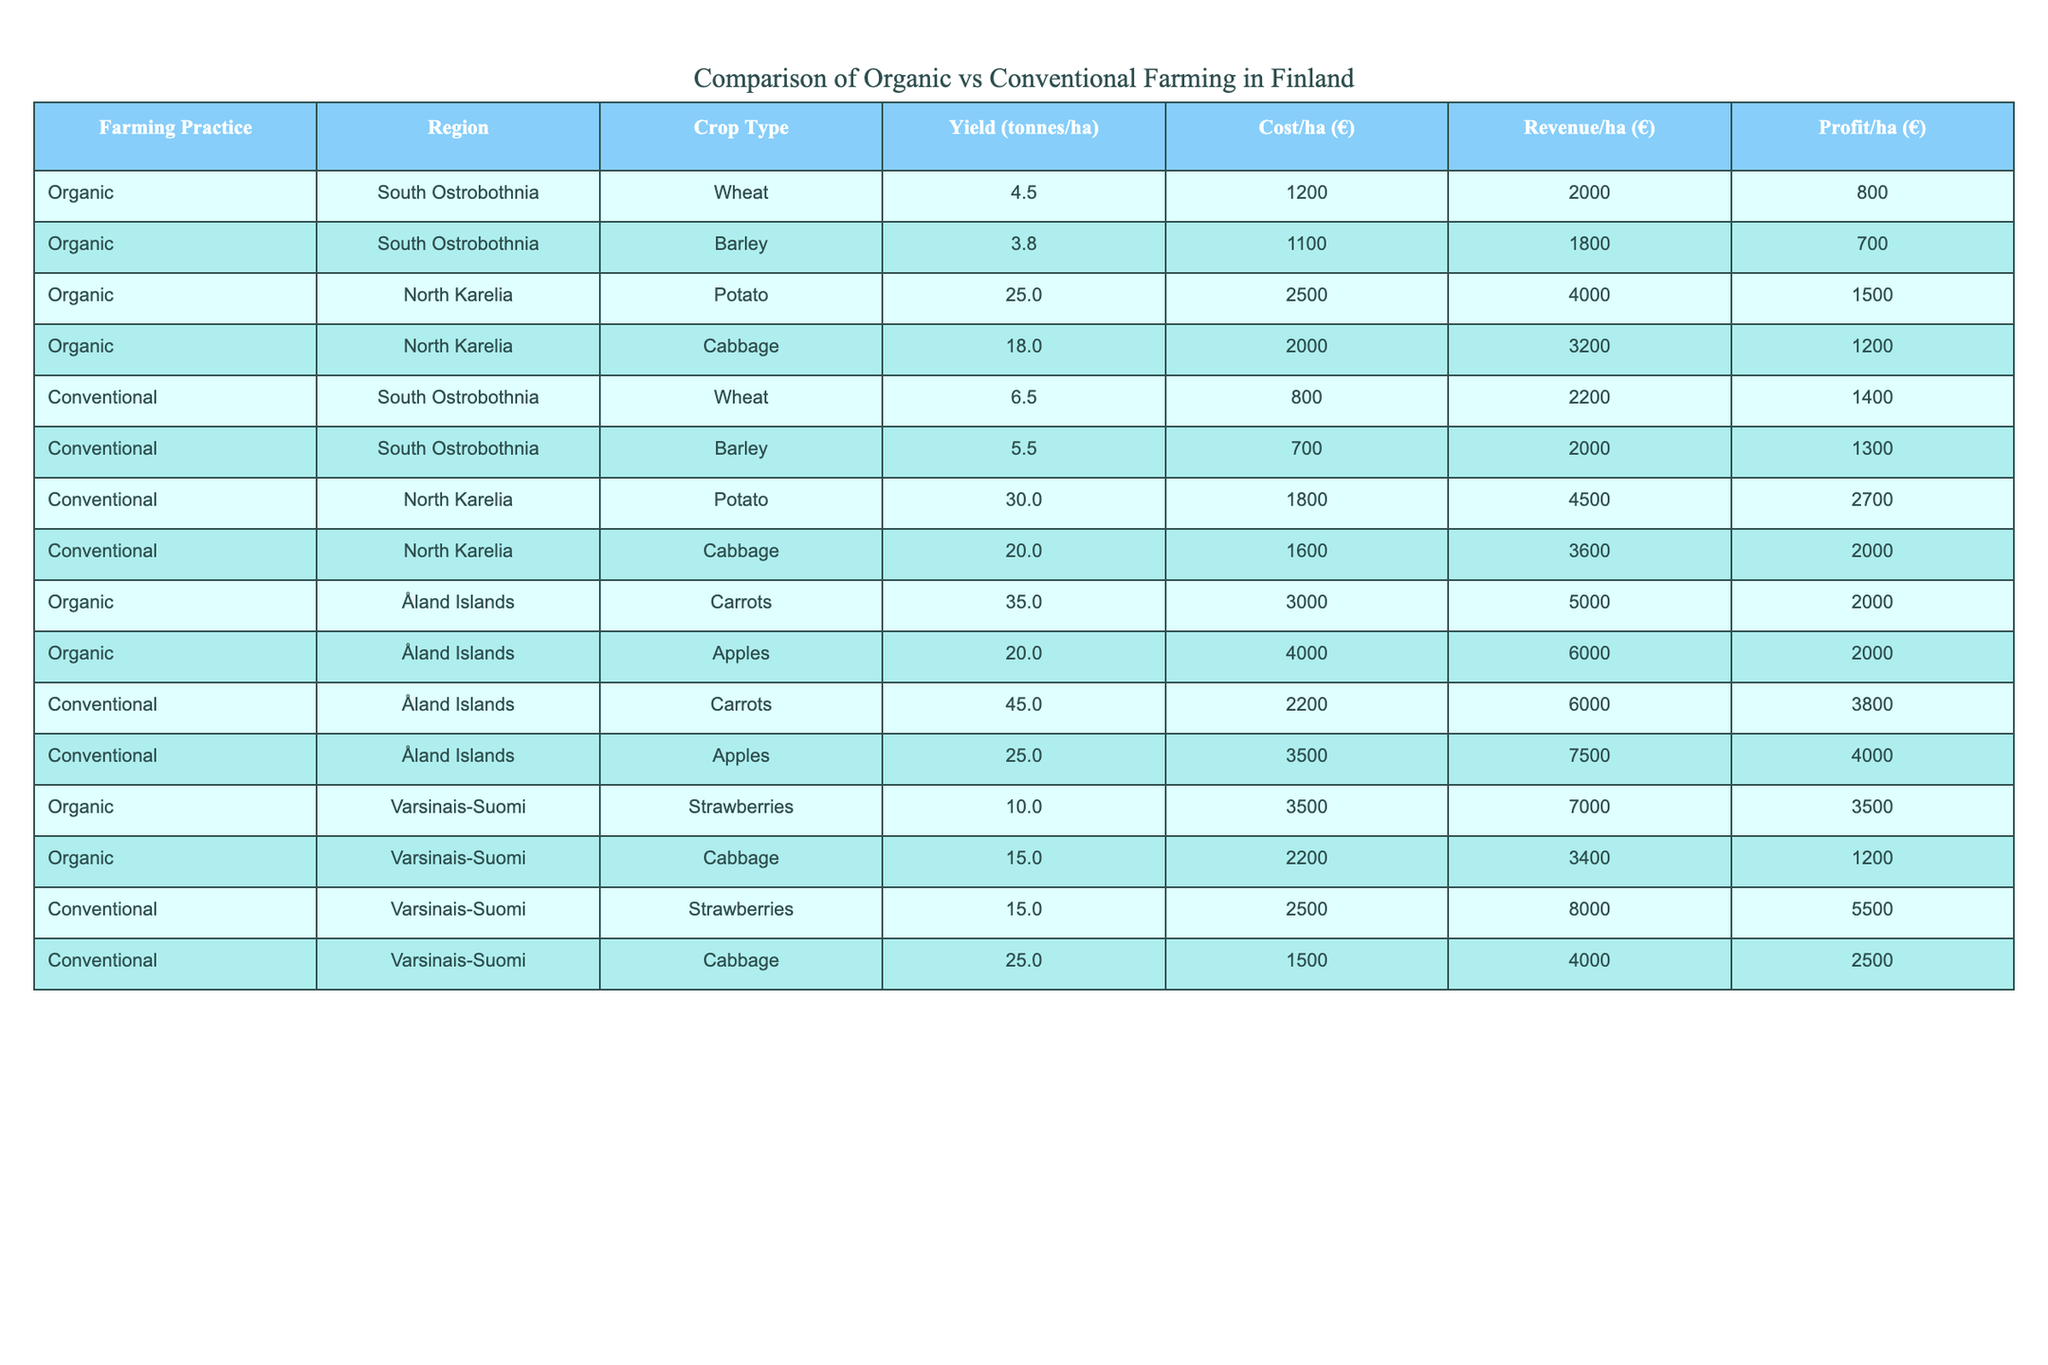What is the yield of conventional wheat in South Ostrobothnia? The yield for conventional wheat in South Ostrobothnia is listed in the table as 6.5 tonnes/ha.
Answer: 6.5 tonnes/ha What is the cost per hectare for organic potatoes in North Karelia? The cost per hectare for organic potatoes in North Karelia is stated as €2500 in the table.
Answer: €2500 Which farming practice has the highest profit per hectare for carrots in Åland Islands? The profit per hectare for organic carrots is €2000, while for conventional carrots it is €3800. Therefore, conventional farming has the highest profit.
Answer: Conventional farming What is the average yield of organic cabbage across the regions? The yields of organic cabbage are 15.0 tonnes/ha (Varsinais-Suomi) and 18.0 tonnes/ha (North Karelia). The average is (15.0 + 18.0) / 2 = 16.5 tonnes/ha.
Answer: 16.5 tonnes/ha How much higher is the profit per hectare for conventional potatoes compared to organic potatoes in North Karelia? The profit for conventional potatoes is €2700 and for organic potatoes, it is €1500. The difference is €2700 - €1500 = €1200, making conventional potatoes €1200 more profitable.
Answer: €1200 Are organic strawberries in Varsinais-Suomi less profitable than conventional strawberries? The profit for organic strawberries is €3500 while for conventional strawberries it is €5500. Since €3500 is less than €5500, organic strawberries are indeed less profitable.
Answer: Yes What is the total revenue generated per hectare for conventional cabbage in South Ostrobothnia? The revenue for conventional cabbage in South Ostrobothnia is €3600 according to the table.
Answer: €3600 Which crop has the highest yield among all farming practices listed? The crop with the highest yield is conventional carrots in Åland Islands, with a yield of 45.0 tonnes/ha, which is more than any other crop listed.
Answer: Conventional carrots (45.0 tonnes/ha) What is the profit margin (profit/revenue) for organic wheat in South Ostrobothnia? The profit for organic wheat is €800 and the revenue is €2000. The profit margin is calculated as €800 / €2000 = 0.4 or 40%.
Answer: 40% Which region shows the greatest profit difference between organic and conventional farming for potatoes? The profit for organic potatoes in North Karelia is €1500 while conventional potatoes have a profit of €2700. The difference is €2700 - €1500 = €1200, showing a significant difference in profit in that region.
Answer: €1200 